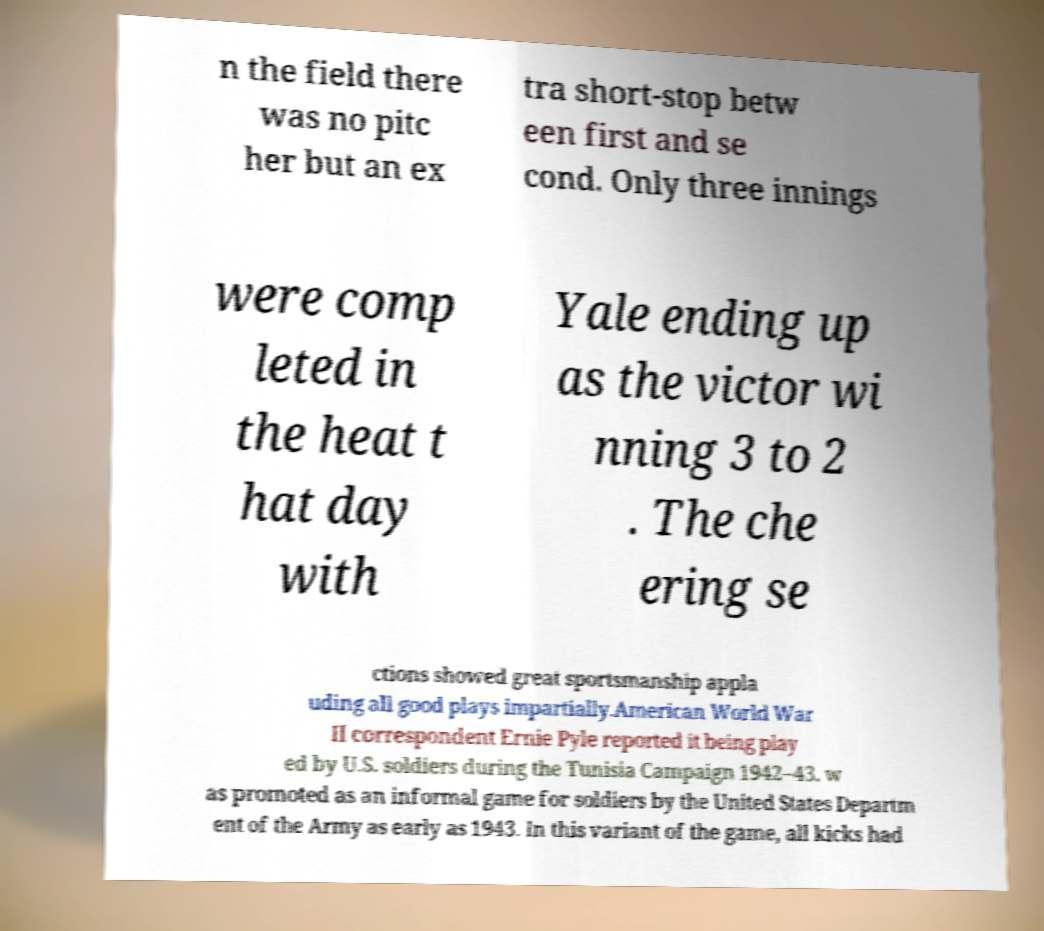I need the written content from this picture converted into text. Can you do that? n the field there was no pitc her but an ex tra short-stop betw een first and se cond. Only three innings were comp leted in the heat t hat day with Yale ending up as the victor wi nning 3 to 2 . The che ering se ctions showed great sportsmanship appla uding all good plays impartially.American World War II correspondent Ernie Pyle reported it being play ed by U.S. soldiers during the Tunisia Campaign 1942–43. w as promoted as an informal game for soldiers by the United States Departm ent of the Army as early as 1943. In this variant of the game, all kicks had 